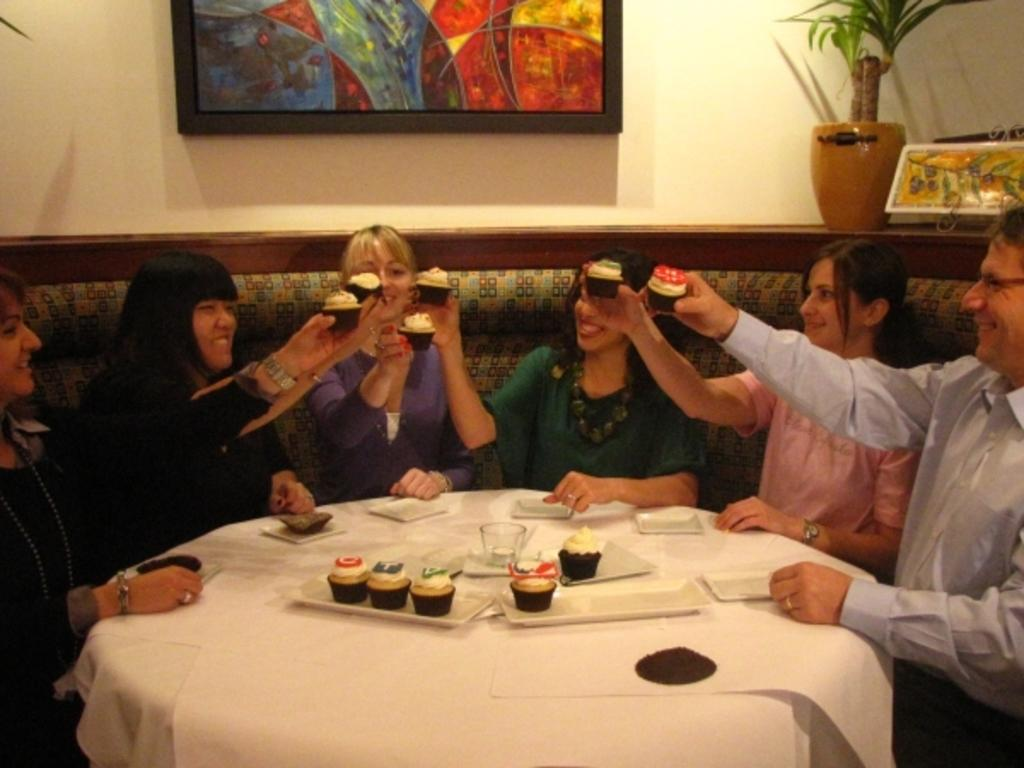How many people are in the room? There are people in the room, but the exact number is not specified. What are the people doing in the room? The people are sitting in front of a table, and they are having a party. What is the purpose of the table in the room? The table is likely being used for serving food or drinks during the party. What is the position of the moon in the room? The moon is not present in the room; it is a celestial body that exists outside. 